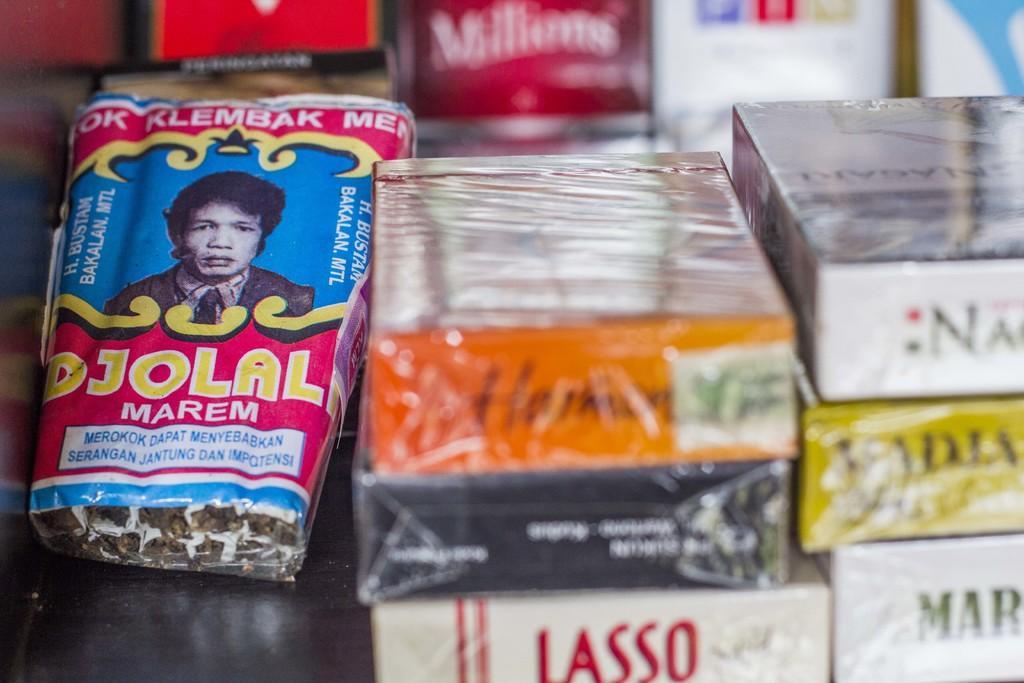Could you give a brief overview of what you see in this image? In this image, we can see few boxes. Left side of the image, we can see some packet. There is a sticker here. Here we can see a human image. Background we can see a blur view. 